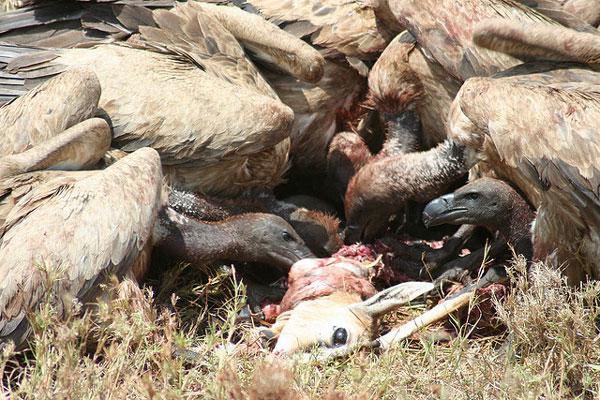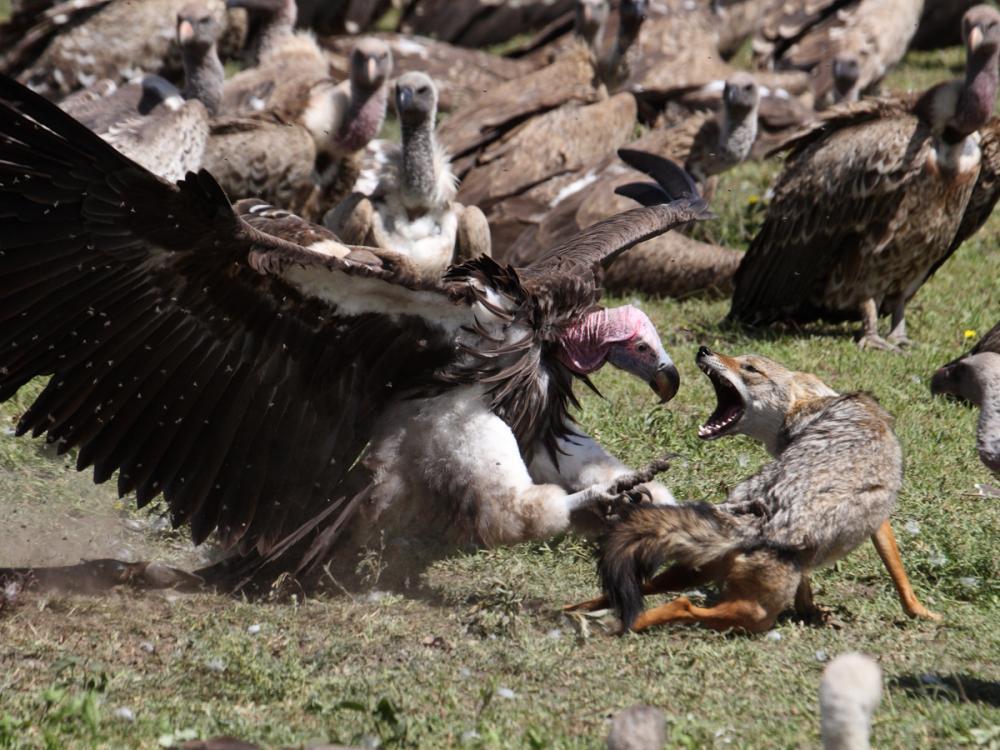The first image is the image on the left, the second image is the image on the right. Given the left and right images, does the statement "An image contains a mass of vultures and a living creature that is not a bird." hold true? Answer yes or no. Yes. The first image is the image on the left, the second image is the image on the right. Considering the images on both sides, is "One of the meals is an antelope like creature, such as a deer." valid? Answer yes or no. Yes. 